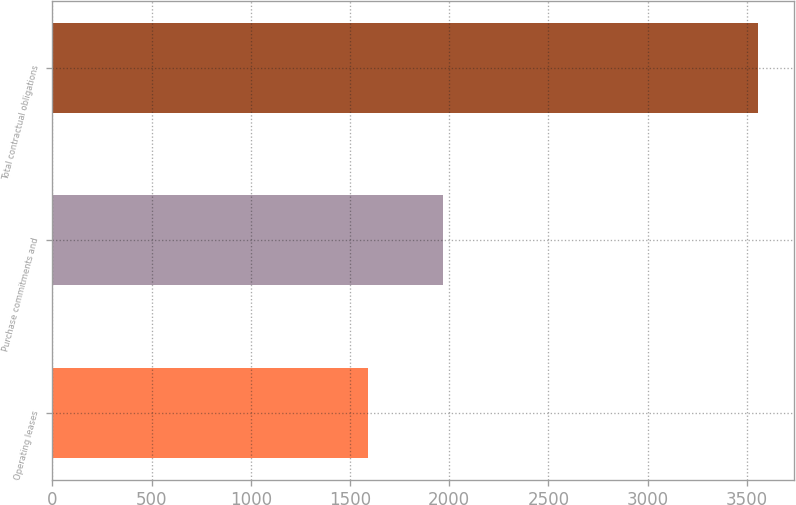Convert chart to OTSL. <chart><loc_0><loc_0><loc_500><loc_500><bar_chart><fcel>Operating leases<fcel>Purchase commitments and<fcel>Total contractual obligations<nl><fcel>1591<fcel>1967<fcel>3558<nl></chart> 